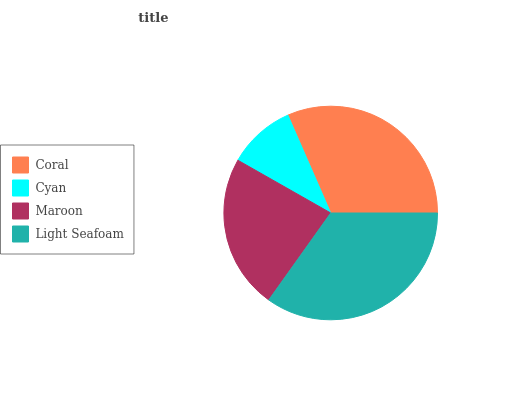Is Cyan the minimum?
Answer yes or no. Yes. Is Light Seafoam the maximum?
Answer yes or no. Yes. Is Maroon the minimum?
Answer yes or no. No. Is Maroon the maximum?
Answer yes or no. No. Is Maroon greater than Cyan?
Answer yes or no. Yes. Is Cyan less than Maroon?
Answer yes or no. Yes. Is Cyan greater than Maroon?
Answer yes or no. No. Is Maroon less than Cyan?
Answer yes or no. No. Is Coral the high median?
Answer yes or no. Yes. Is Maroon the low median?
Answer yes or no. Yes. Is Maroon the high median?
Answer yes or no. No. Is Light Seafoam the low median?
Answer yes or no. No. 